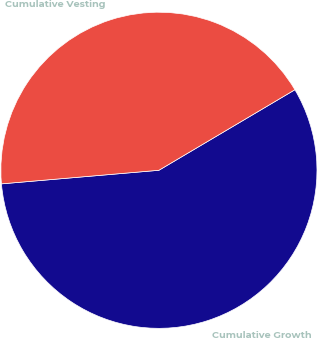Convert chart to OTSL. <chart><loc_0><loc_0><loc_500><loc_500><pie_chart><fcel>Cumulative Growth<fcel>Cumulative Vesting<nl><fcel>57.14%<fcel>42.86%<nl></chart> 